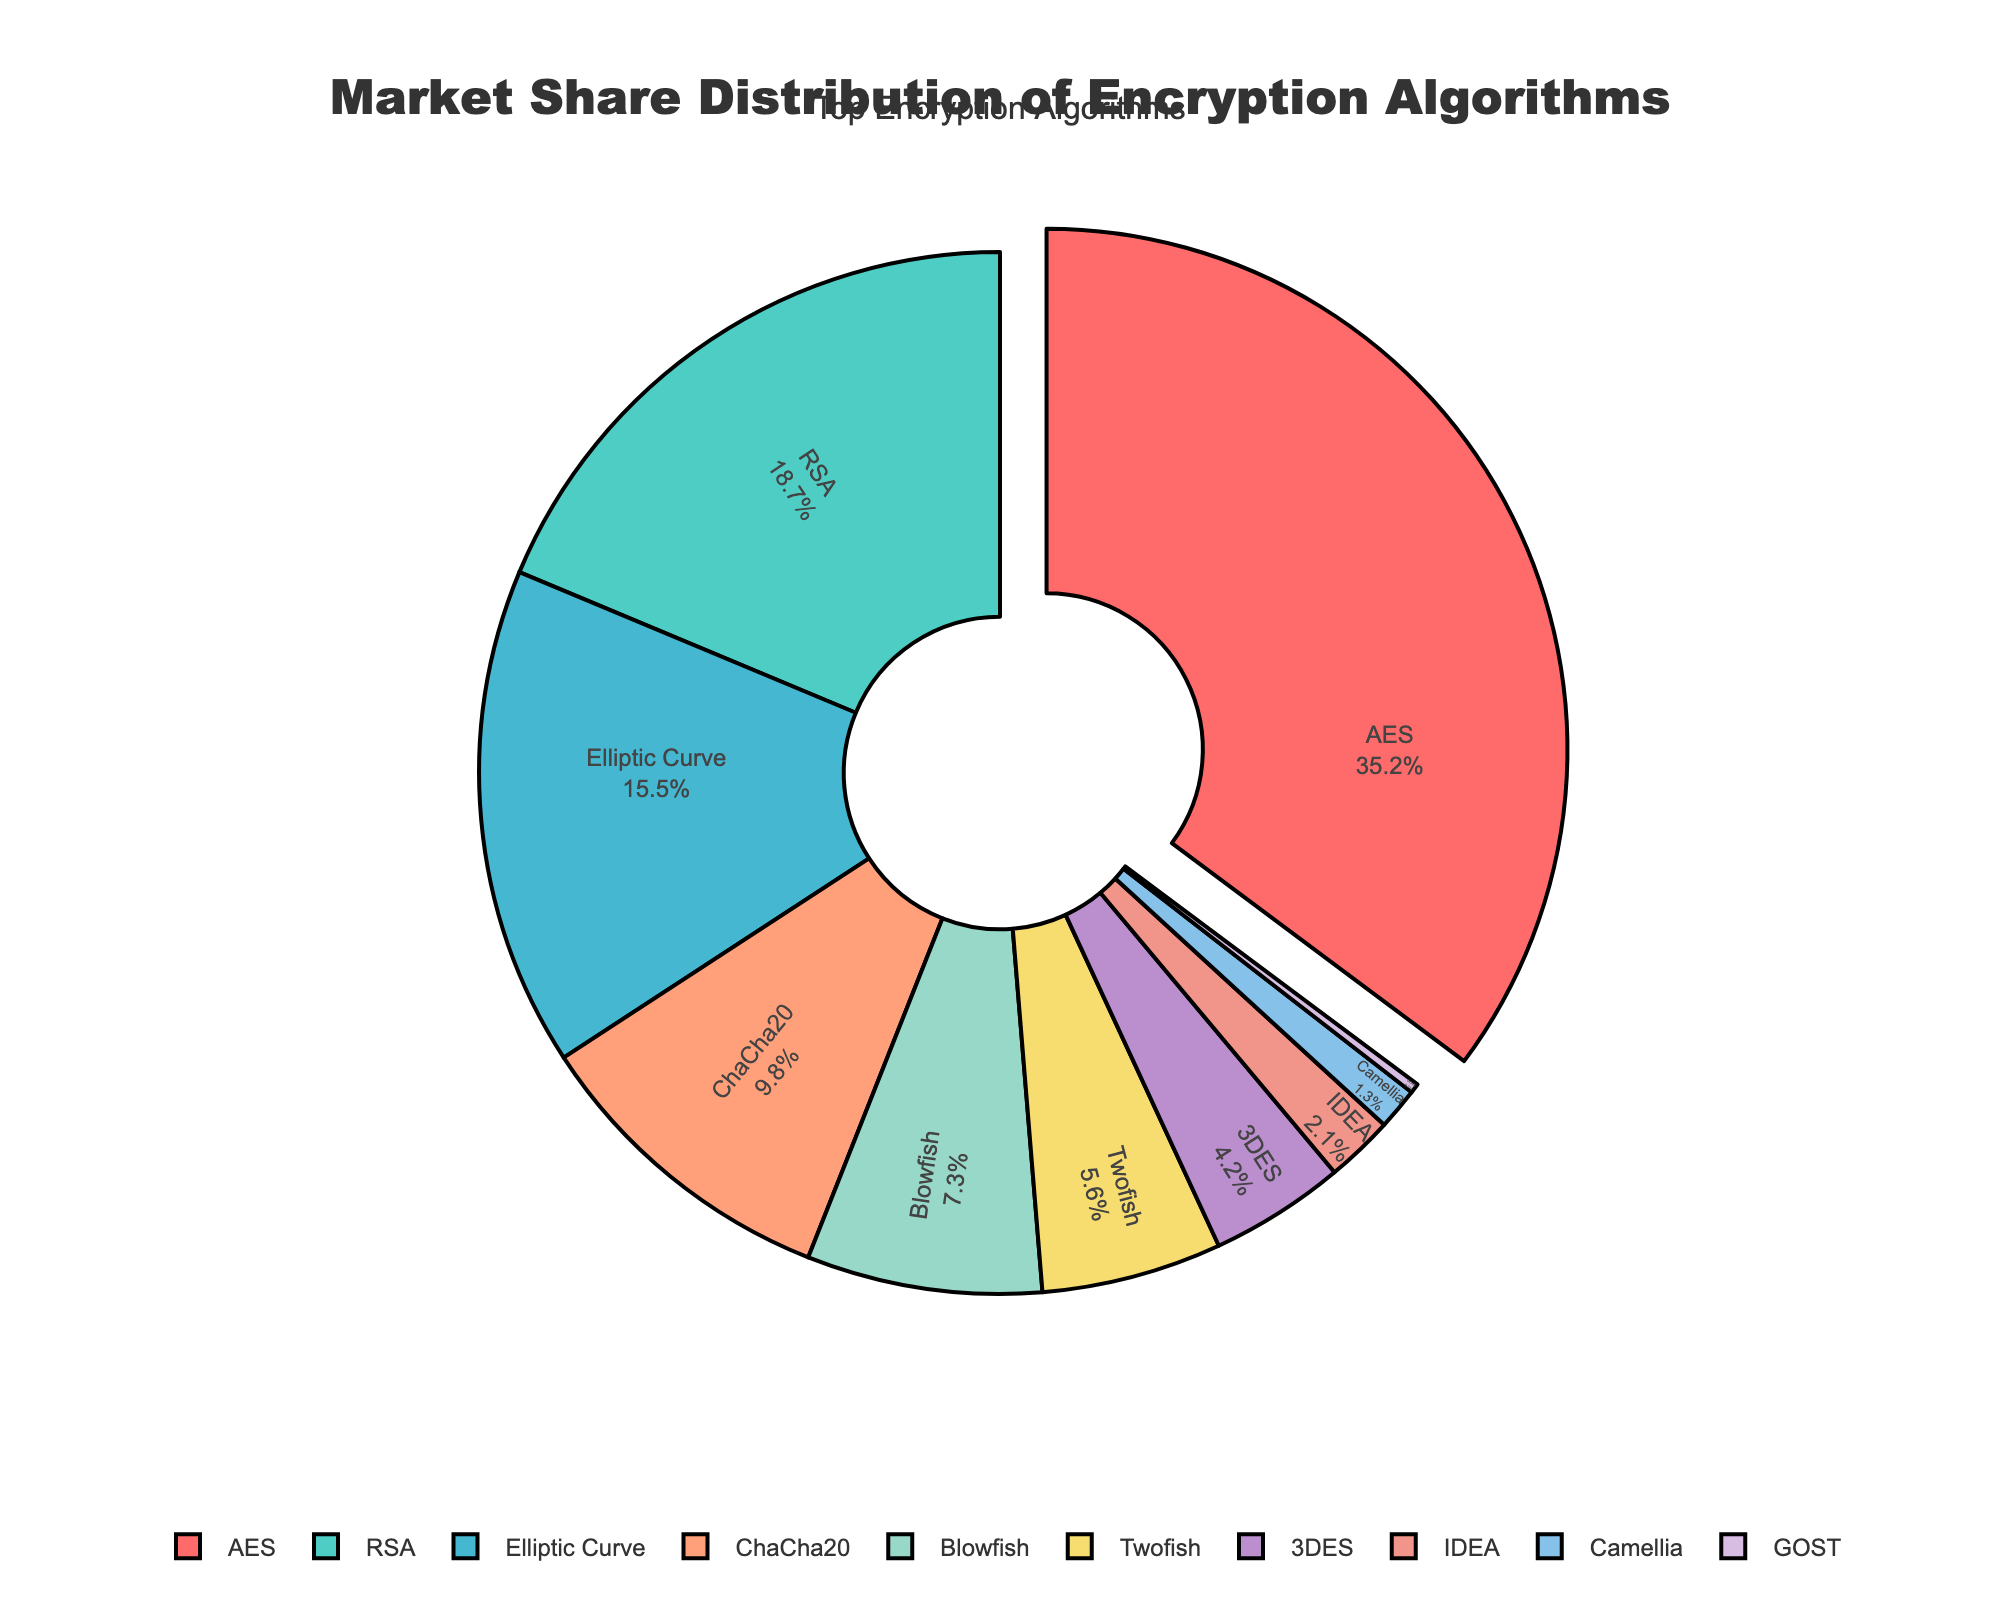What is the highest market share of any encryption algorithm in the figure? The figure shows the market share distribution of encryption algorithms. AES has the largest slice, representing the highest market share.
Answer: 35.2% What is the combined market share of ChaCha20 and Blowfish? The market shares of ChaCha20 and Blowfish are 9.8% and 7.3%, respectively. Adding them together, 9.8 + 7.3 = 17.1%.
Answer: 17.1% By how much does RSA's market share exceed that of Twofish? RSA's market share is 18.7%, and Twofish's is 5.6%. The difference is 18.7 - 5.6 = 13.1%.
Answer: 13.1% Which algorithm has the smallest market share? The smallest slice in the chart corresponds to GOST, which has the smallest market share.
Answer: GOST What is the total market share for algorithms having less than 5% share? Algorithms with less than 5% share are 3DES (4.2%), IDEA (2.1%), Camellia (1.3%), and GOST (0.3%). Summing them up: 4.2 + 2.1 + 1.3 + 0.3 = 7.9%.
Answer: 7.9% What is the visual attribute that distinguishes AES from the other algorithms? The slice representing AES is pulled out slightly from the rest, highlighting it.
Answer: Pulled out slice What is the market share difference between the two least popular algorithms? The two least popular algorithms are Camellia (1.3%) and GOST (0.3%). The difference is 1.3 - 0.3 = 1.0%.
Answer: 1.0% Considering the top three algorithms by market share, what is their combined market share? The top three algorithms are AES (35.2%), RSA (18.7%), and Elliptic Curve (15.5%). Their combined share is 35.2 + 18.7 + 15.5 = 69.4%.
Answer: 69.4% How many algorithms have a market share greater than 10%? The algorithms with a market share greater than 10% are AES (35.2%), RSA (18.7%), and Elliptic Curve (15.5%). There are three such algorithms.
Answer: 3 